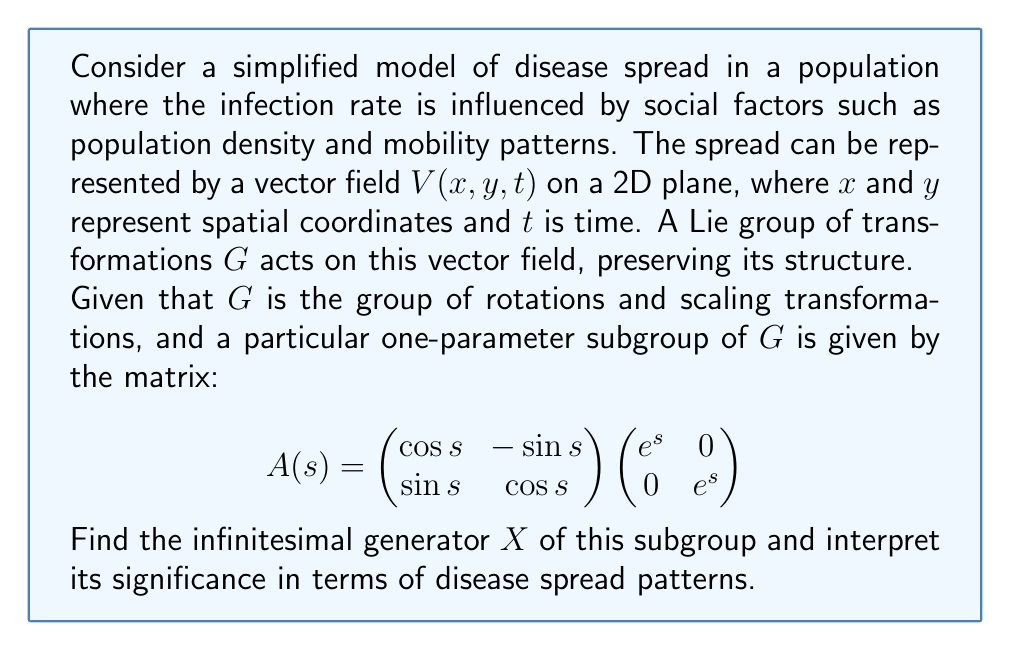Provide a solution to this math problem. To solve this problem, we'll follow these steps:

1) The infinitesimal generator $X$ is found by differentiating $A(s)$ with respect to $s$ at $s=0$:

   $$X = \frac{d}{ds}A(s)\bigg|_{s=0}$$

2) Let's differentiate $A(s)$:

   $$\frac{d}{ds}A(s) = \frac{d}{ds}\left(\begin{pmatrix}
   \cos s & -\sin s \\
   \sin s & \cos s
   \end{pmatrix} \begin{pmatrix}
   e^s & 0 \\
   0 & e^s
   \end{pmatrix}\right)$$

   $$= \begin{pmatrix}
   -\sin s & -\cos s \\
   \cos s & -\sin s
   \end{pmatrix} \begin{pmatrix}
   e^s & 0 \\
   0 & e^s
   \end{pmatrix} + \begin{pmatrix}
   \cos s & -\sin s \\
   \sin s & \cos s
   \end{pmatrix} \begin{pmatrix}
   e^s & 0 \\
   0 & e^s
   \end{pmatrix}$$

3) Evaluating at $s=0$:

   $$X = \begin{pmatrix}
   -\sin 0 & -\cos 0 \\
   \cos 0 & -\sin 0
   \end{pmatrix} \begin{pmatrix}
   1 & 0 \\
   0 & 1
   \end{pmatrix} + \begin{pmatrix}
   \cos 0 & -\sin 0 \\
   \sin 0 & \cos 0
   \end{pmatrix} \begin{pmatrix}
   1 & 0 \\
   0 & 1
   \end{pmatrix}$$

   $$= \begin{pmatrix}
   0 & -1 \\
   1 & 0
   \end{pmatrix} + \begin{pmatrix}
   1 & 0 \\
   0 & 1
   \end{pmatrix} = \begin{pmatrix}
   1 & -1 \\
   1 & 1
   \end{pmatrix}$$

4) Interpretation: The infinitesimal generator $X$ represents the instantaneous change in the disease spread pattern under the action of the Lie group. The matrix $X$ can be decomposed into two parts:

   $$X = \begin{pmatrix}
   0 & -1 \\
   1 & 0
   \end{pmatrix} + \begin{pmatrix}
   1 & 0 \\
   0 & 1
   \end{pmatrix}$$

   The first matrix represents rotation, while the second represents scaling.

   In terms of disease spread, this suggests that the pattern undergoes both a rotation (changing the direction of spread) and an expansion (increasing the overall affected area) simultaneously. The rotation could represent changes in population movement patterns, while the scaling could represent an increase in the rate of spread due to social factors like increased population density or mobility.
Answer: The infinitesimal generator $X$ is:

$$X = \begin{pmatrix}
1 & -1 \\
1 & 1
\end{pmatrix}$$

This represents a combination of rotation and scaling in the disease spread pattern, indicating simultaneous changes in the direction and rate of disease propagation due to social factors. 